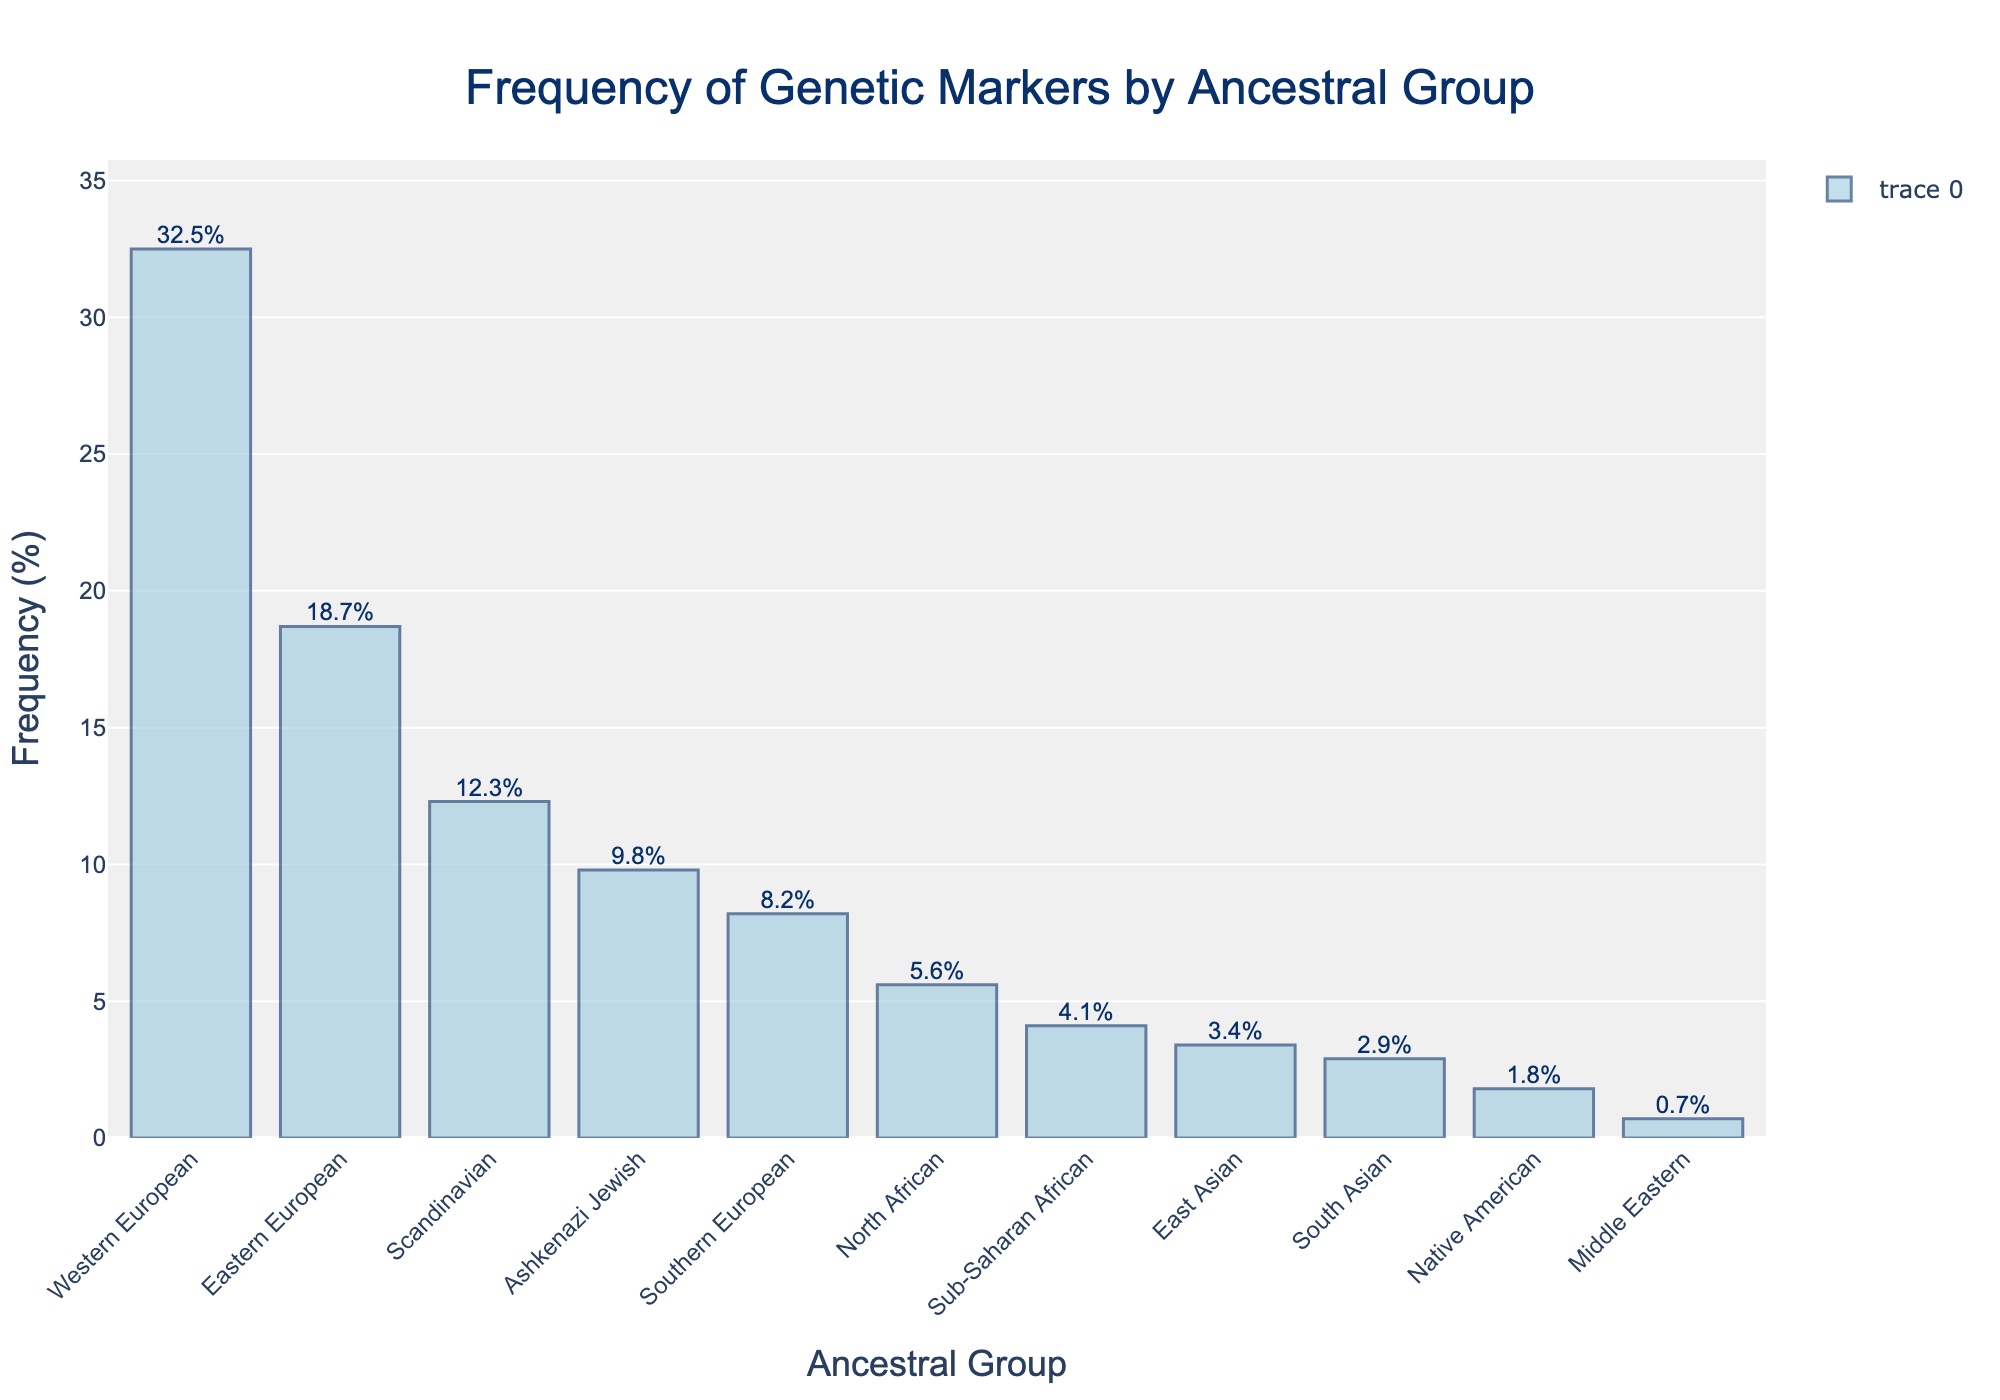Which ancestral group has the highest frequency of genetic markers? By looking at the height of the bars, the Western European ancestral group has the tallest bar, indicating it has the highest frequency of genetic markers.
Answer: Western European What is the combined frequency of the Eastern European and Ashkenazi Jewish ancestral groups? The frequency of Eastern European is 18.7% and Ashkenazi Jewish is 9.8%. Adding these frequencies together gives: 18.7 + 9.8 = 28.5%.
Answer: 28.5% Which ancestral group has a frequency of genetic markers lower than 1%? By examining the values on top of each bar, the Middle Eastern ancestral group has a frequency of 0.7%, which is lower than 1%.
Answer: Middle Eastern How much higher is the frequency of the Western European group compared to the Scandinavian group? The frequency of Western European is 32.5% and Scandinavian is 12.3%. Subtracting these gives: 32.5 - 12.3 = 20.2%.
Answer: 20.2% Order the ancestral groups by frequency of genetic markers from highest to lowest. By sorting the bars from tallest to shortest, the order is: Western European, Eastern European, Scandinavian, Ashkenazi Jewish, Southern European, North African, Sub-Saharan African, East Asian, South Asian, Native American, Middle Eastern.
Answer: Western European, Eastern European, Scandinavian, Ashkenazi Jewish, Southern European, North African, Sub-Saharan African, East Asian, South Asian, Native American, Middle Eastern What is the average frequency of the North African, Sub-Saharan African, East Asian, and South Asian ancestral groups? The frequencies are North African 5.6%, Sub-Saharan African 4.1%, East Asian 3.4%, and South Asian 2.9%. Summing these: 5.6 + 4.1 + 3.4 + 2.9 = 16. Adding the averages together and dividing by 4 gives: 16 / 4 = 4%.
Answer: 4% Are there more ancestral groups with frequencies above 10% or below 10%? Groups with frequencies above 10%: Western European (32.5%), Eastern European (18.7%), Scandinavian (12.3%), and groups with frequencies below 10%: Ashkenazi Jewish (9.8%), Southern European (8.2%), North African (5.6%), Sub-Saharan African (4.1%), East Asian (3.4%), South Asian (2.9%), Native American (1.8%), Middle Eastern (0.7%). There are 3 groups above 10% and 8 groups below 10%.
Answer: Below 10% What is the cumulative frequency of the top three ancestral groups? The top three groups, based on frequency, are Western European (32.5%), Eastern European (18.7%), and Scandinavian (12.3%). Adding these frequencies gives: 32.5 + 18.7 + 12.3 = 63.5%.
Answer: 63.5% Which ancestral group has the closest frequency to 10%? By examining the values on top of each bar, Ashkenazi Jewish has a frequency of 9.8%, which is closest to 10%.
Answer: Ashkenazi Jewish 